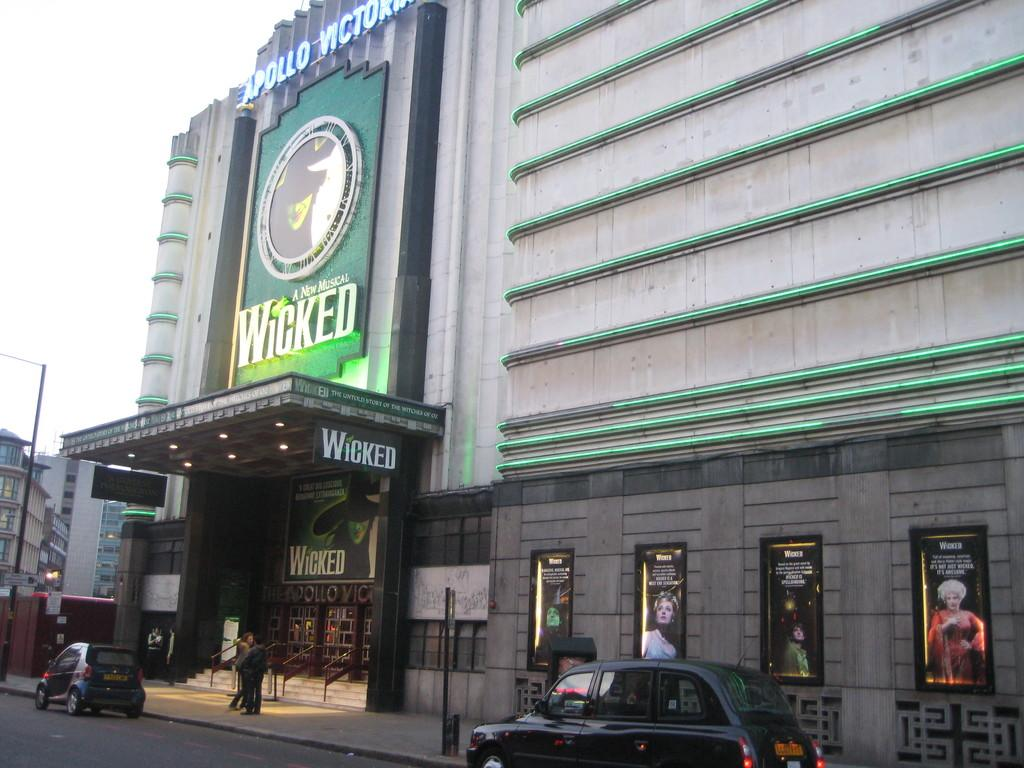Provide a one-sentence caption for the provided image. An outside of a movie theater featuring a New Musical Wicked. 